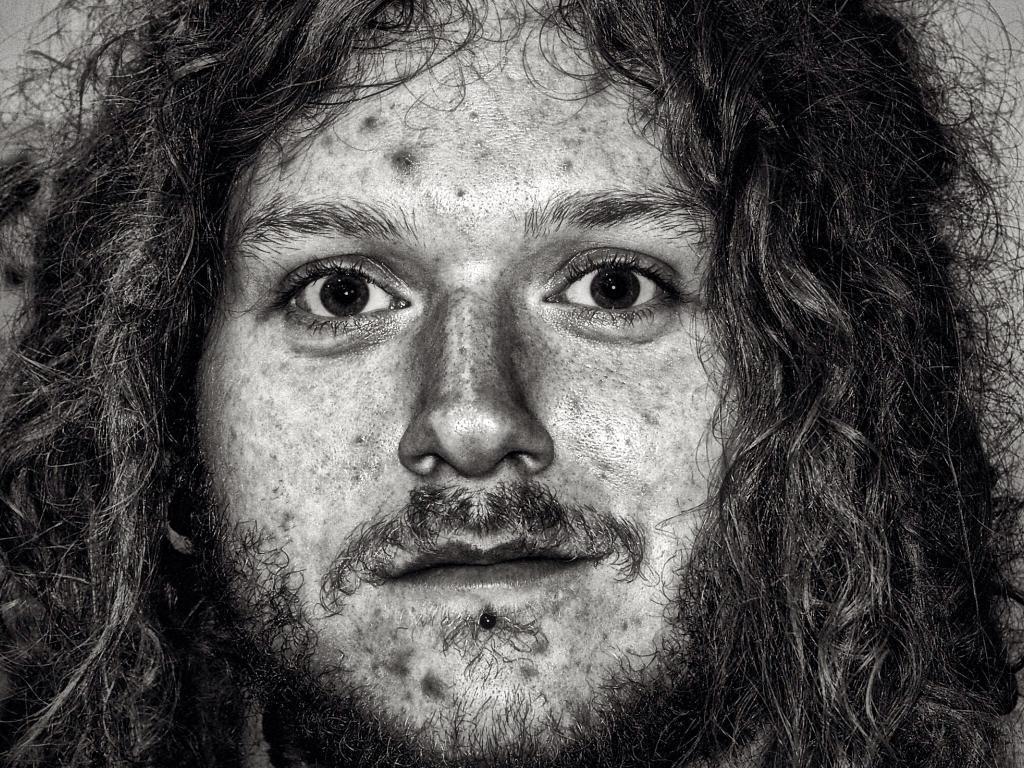Can you describe this image briefly? This looks like a black and white image. I can see the face of the man with the mustache, beard and hair. 